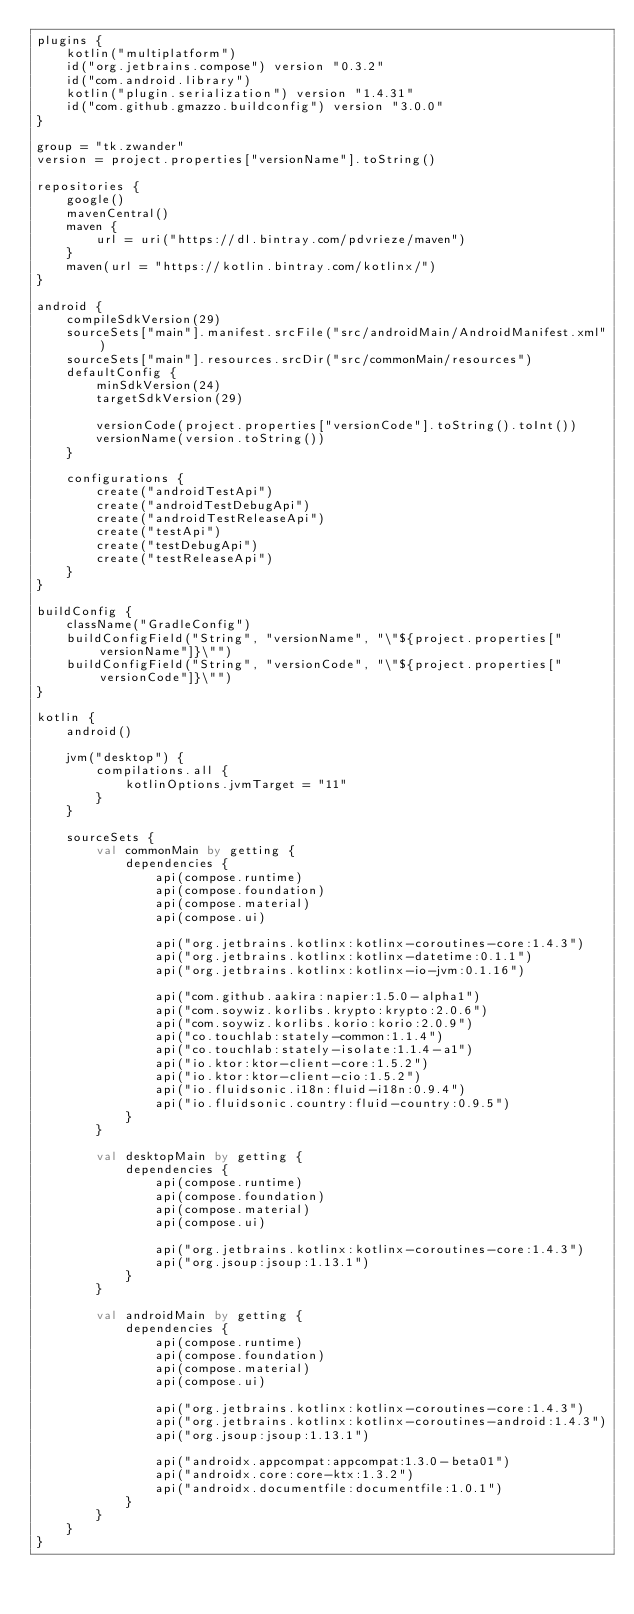Convert code to text. <code><loc_0><loc_0><loc_500><loc_500><_Kotlin_>plugins {
    kotlin("multiplatform")
    id("org.jetbrains.compose") version "0.3.2"
    id("com.android.library")
    kotlin("plugin.serialization") version "1.4.31"
    id("com.github.gmazzo.buildconfig") version "3.0.0"
}

group = "tk.zwander"
version = project.properties["versionName"].toString()

repositories {
    google()
    mavenCentral()
    maven {
        url = uri("https://dl.bintray.com/pdvrieze/maven")
    }
    maven(url = "https://kotlin.bintray.com/kotlinx/")
}

android {
    compileSdkVersion(29)
    sourceSets["main"].manifest.srcFile("src/androidMain/AndroidManifest.xml")
    sourceSets["main"].resources.srcDir("src/commonMain/resources")
    defaultConfig {
        minSdkVersion(24)
        targetSdkVersion(29)

        versionCode(project.properties["versionCode"].toString().toInt())
        versionName(version.toString())
    }

    configurations {
        create("androidTestApi")
        create("androidTestDebugApi")
        create("androidTestReleaseApi")
        create("testApi")
        create("testDebugApi")
        create("testReleaseApi")
    }
}

buildConfig {
    className("GradleConfig")
    buildConfigField("String", "versionName", "\"${project.properties["versionName"]}\"")
    buildConfigField("String", "versionCode", "\"${project.properties["versionCode"]}\"")
}

kotlin {
    android()

    jvm("desktop") {
        compilations.all {
            kotlinOptions.jvmTarget = "11"
        }
    }
    
    sourceSets {
        val commonMain by getting {
            dependencies {
                api(compose.runtime)
                api(compose.foundation)
                api(compose.material)
                api(compose.ui)

                api("org.jetbrains.kotlinx:kotlinx-coroutines-core:1.4.3")
                api("org.jetbrains.kotlinx:kotlinx-datetime:0.1.1")
                api("org.jetbrains.kotlinx:kotlinx-io-jvm:0.1.16")

                api("com.github.aakira:napier:1.5.0-alpha1")
                api("com.soywiz.korlibs.krypto:krypto:2.0.6")
                api("com.soywiz.korlibs.korio:korio:2.0.9")
                api("co.touchlab:stately-common:1.1.4")
                api("co.touchlab:stately-isolate:1.1.4-a1")
                api("io.ktor:ktor-client-core:1.5.2")
                api("io.ktor:ktor-client-cio:1.5.2")
                api("io.fluidsonic.i18n:fluid-i18n:0.9.4")
                api("io.fluidsonic.country:fluid-country:0.9.5")
            }
        }

        val desktopMain by getting {
            dependencies {
                api(compose.runtime)
                api(compose.foundation)
                api(compose.material)
                api(compose.ui)

                api("org.jetbrains.kotlinx:kotlinx-coroutines-core:1.4.3")
                api("org.jsoup:jsoup:1.13.1")
            }
        }

        val androidMain by getting {
            dependencies {
                api(compose.runtime)
                api(compose.foundation)
                api(compose.material)
                api(compose.ui)

                api("org.jetbrains.kotlinx:kotlinx-coroutines-core:1.4.3")
                api("org.jetbrains.kotlinx:kotlinx-coroutines-android:1.4.3")
                api("org.jsoup:jsoup:1.13.1")

                api("androidx.appcompat:appcompat:1.3.0-beta01")
                api("androidx.core:core-ktx:1.3.2")
                api("androidx.documentfile:documentfile:1.0.1")
            }
        }
    }
}</code> 